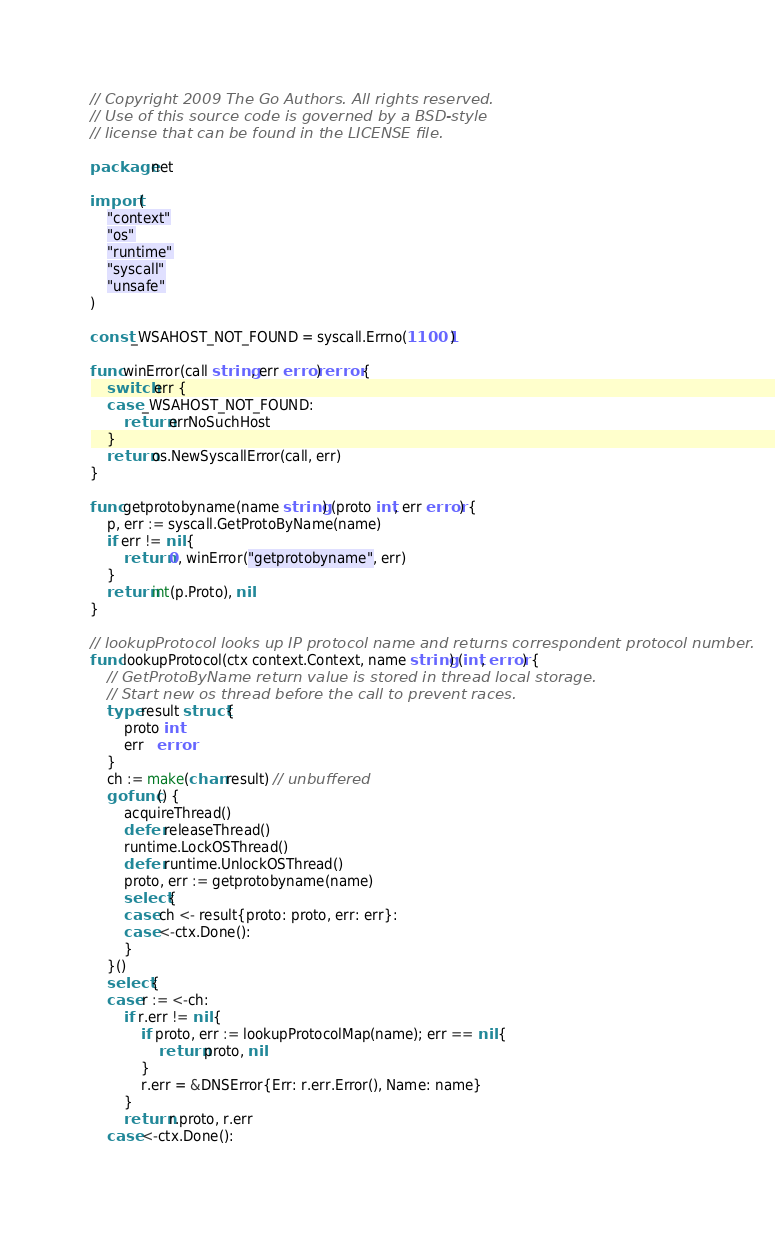Convert code to text. <code><loc_0><loc_0><loc_500><loc_500><_Go_>// Copyright 2009 The Go Authors. All rights reserved.
// Use of this source code is governed by a BSD-style
// license that can be found in the LICENSE file.

package net

import (
	"context"
	"os"
	"runtime"
	"syscall"
	"unsafe"
)

const _WSAHOST_NOT_FOUND = syscall.Errno(11001)

func winError(call string, err error) error {
	switch err {
	case _WSAHOST_NOT_FOUND:
		return errNoSuchHost
	}
	return os.NewSyscallError(call, err)
}

func getprotobyname(name string) (proto int, err error) {
	p, err := syscall.GetProtoByName(name)
	if err != nil {
		return 0, winError("getprotobyname", err)
	}
	return int(p.Proto), nil
}

// lookupProtocol looks up IP protocol name and returns correspondent protocol number.
func lookupProtocol(ctx context.Context, name string) (int, error) {
	// GetProtoByName return value is stored in thread local storage.
	// Start new os thread before the call to prevent races.
	type result struct {
		proto int
		err   error
	}
	ch := make(chan result) // unbuffered
	go func() {
		acquireThread()
		defer releaseThread()
		runtime.LockOSThread()
		defer runtime.UnlockOSThread()
		proto, err := getprotobyname(name)
		select {
		case ch <- result{proto: proto, err: err}:
		case <-ctx.Done():
		}
	}()
	select {
	case r := <-ch:
		if r.err != nil {
			if proto, err := lookupProtocolMap(name); err == nil {
				return proto, nil
			}
			r.err = &DNSError{Err: r.err.Error(), Name: name}
		}
		return r.proto, r.err
	case <-ctx.Done():</code> 